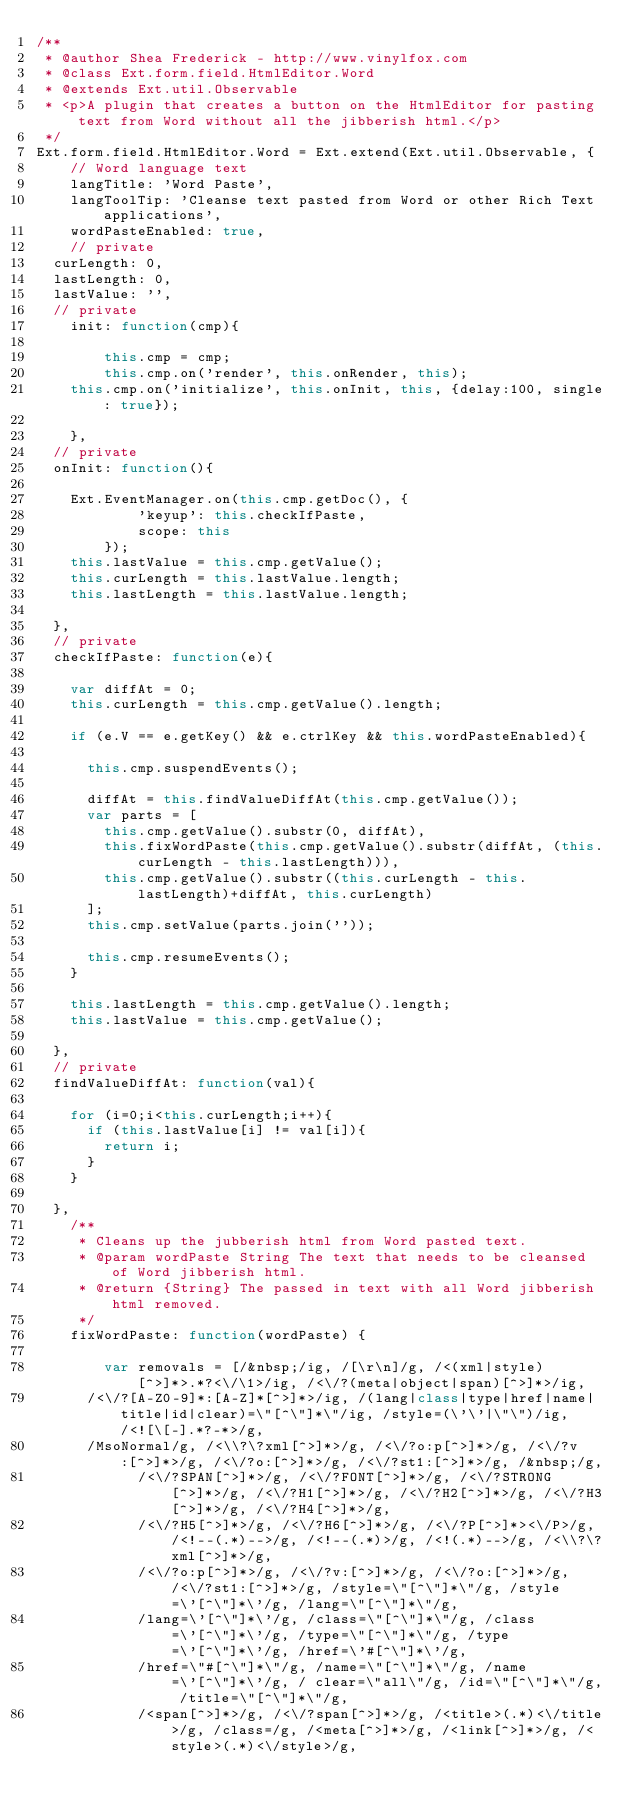<code> <loc_0><loc_0><loc_500><loc_500><_JavaScript_>/**
 * @author Shea Frederick - http://www.vinylfox.com
 * @class Ext.form.field.HtmlEditor.Word
 * @extends Ext.util.Observable
 * <p>A plugin that creates a button on the HtmlEditor for pasting text from Word without all the jibberish html.</p>
 */
Ext.form.field.HtmlEditor.Word = Ext.extend(Ext.util.Observable, {
    // Word language text
    langTitle: 'Word Paste',
    langToolTip: 'Cleanse text pasted from Word or other Rich Text applications',
    wordPasteEnabled: true,
    // private
	curLength: 0,
	lastLength: 0,
	lastValue: '',
	// private
    init: function(cmp){
        
        this.cmp = cmp;
        this.cmp.on('render', this.onRender, this);
		this.cmp.on('initialize', this.onInit, this, {delay:100, single: true});
        
    },
	// private
	onInit: function(){
		
		Ext.EventManager.on(this.cmp.getDoc(), {
            'keyup': this.checkIfPaste,
            scope: this
        });
		this.lastValue = this.cmp.getValue();
		this.curLength = this.lastValue.length;
		this.lastLength = this.lastValue.length;
		
	},
	// private
	checkIfPaste: function(e){
		
		var diffAt = 0;
		this.curLength = this.cmp.getValue().length;
		
		if (e.V == e.getKey() && e.ctrlKey && this.wordPasteEnabled){
			
			this.cmp.suspendEvents();
			
			diffAt = this.findValueDiffAt(this.cmp.getValue());
			var parts = [
				this.cmp.getValue().substr(0, diffAt),
				this.fixWordPaste(this.cmp.getValue().substr(diffAt, (this.curLength - this.lastLength))),
				this.cmp.getValue().substr((this.curLength - this.lastLength)+diffAt, this.curLength)
			];
			this.cmp.setValue(parts.join(''));
			
			this.cmp.resumeEvents();
		}
		
		this.lastLength = this.cmp.getValue().length;
		this.lastValue = this.cmp.getValue();
		
	},
	// private
	findValueDiffAt: function(val){
		
		for (i=0;i<this.curLength;i++){
			if (this.lastValue[i] != val[i]){
				return i;			
			}
		}
		
	},
    /**
     * Cleans up the jubberish html from Word pasted text.
     * @param wordPaste String The text that needs to be cleansed of Word jibberish html.
     * @return {String} The passed in text with all Word jibberish html removed.
     */
    fixWordPaste: function(wordPaste) {
        
        var removals = [/&nbsp;/ig, /[\r\n]/g, /<(xml|style)[^>]*>.*?<\/\1>/ig, /<\/?(meta|object|span)[^>]*>/ig,
			/<\/?[A-Z0-9]*:[A-Z]*[^>]*>/ig, /(lang|class|type|href|name|title|id|clear)=\"[^\"]*\"/ig, /style=(\'\'|\"\")/ig, /<![\[-].*?-*>/g, 
			/MsoNormal/g, /<\\?\?xml[^>]*>/g, /<\/?o:p[^>]*>/g, /<\/?v:[^>]*>/g, /<\/?o:[^>]*>/g, /<\/?st1:[^>]*>/g, /&nbsp;/g, 
            /<\/?SPAN[^>]*>/g, /<\/?FONT[^>]*>/g, /<\/?STRONG[^>]*>/g, /<\/?H1[^>]*>/g, /<\/?H2[^>]*>/g, /<\/?H3[^>]*>/g, /<\/?H4[^>]*>/g, 
            /<\/?H5[^>]*>/g, /<\/?H6[^>]*>/g, /<\/?P[^>]*><\/P>/g, /<!--(.*)-->/g, /<!--(.*)>/g, /<!(.*)-->/g, /<\\?\?xml[^>]*>/g, 
            /<\/?o:p[^>]*>/g, /<\/?v:[^>]*>/g, /<\/?o:[^>]*>/g, /<\/?st1:[^>]*>/g, /style=\"[^\"]*\"/g, /style=\'[^\"]*\'/g, /lang=\"[^\"]*\"/g, 
            /lang=\'[^\"]*\'/g, /class=\"[^\"]*\"/g, /class=\'[^\"]*\'/g, /type=\"[^\"]*\"/g, /type=\'[^\"]*\'/g, /href=\'#[^\"]*\'/g, 
            /href=\"#[^\"]*\"/g, /name=\"[^\"]*\"/g, /name=\'[^\"]*\'/g, / clear=\"all\"/g, /id=\"[^\"]*\"/g, /title=\"[^\"]*\"/g, 
            /<span[^>]*>/g, /<\/?span[^>]*>/g, /<title>(.*)<\/title>/g, /class=/g, /<meta[^>]*>/g, /<link[^>]*>/g, /<style>(.*)<\/style>/g, </code> 